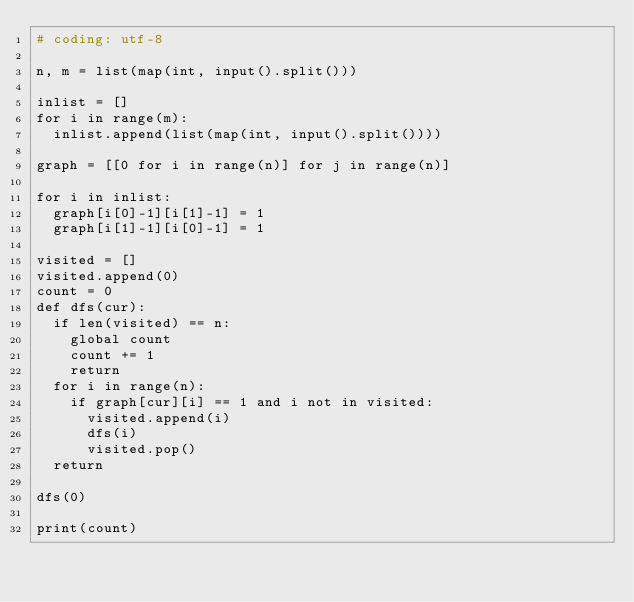<code> <loc_0><loc_0><loc_500><loc_500><_Python_># coding: utf-8

n, m = list(map(int, input().split()))

inlist = []
for i in range(m):
	inlist.append(list(map(int, input().split())))

graph = [[0 for i in range(n)] for j in range(n)]

for i in inlist:
	graph[i[0]-1][i[1]-1] = 1
	graph[i[1]-1][i[0]-1] = 1

visited = []
visited.append(0)
count = 0
def dfs(cur):
	if len(visited) == n:
		global count
		count += 1
		return
	for i in range(n):
		if graph[cur][i] == 1 and i not in visited:
			visited.append(i)
			dfs(i)
			visited.pop()
	return

dfs(0)

print(count)
</code> 